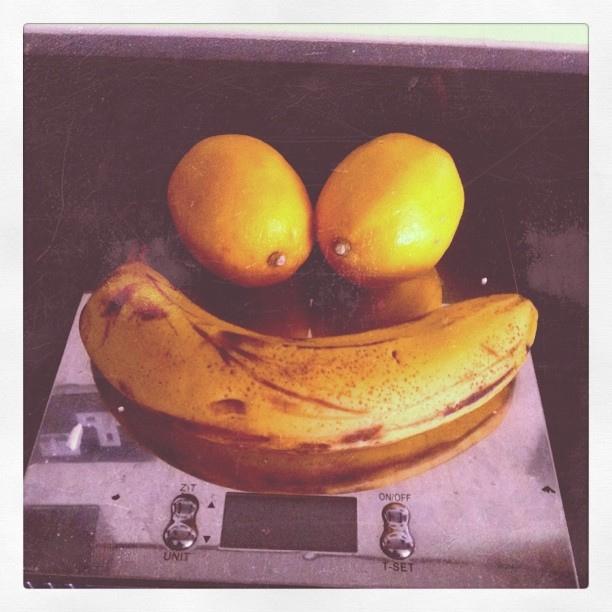How many bananas are in this picture?
Quick response, please. 1. Do the oranges and banana look like a smiley face?
Concise answer only. Yes. Which objects match?
Short answer required. Lemons. 